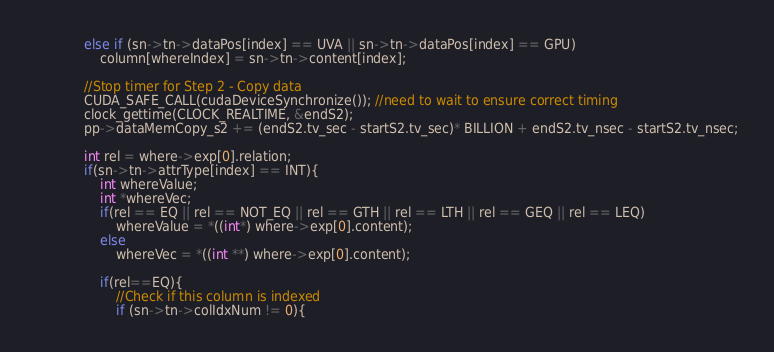<code> <loc_0><loc_0><loc_500><loc_500><_Cuda_>            else if (sn->tn->dataPos[index] == UVA || sn->tn->dataPos[index] == GPU)
                column[whereIndex] = sn->tn->content[index];

            //Stop timer for Step 2 - Copy data
            CUDA_SAFE_CALL(cudaDeviceSynchronize()); //need to wait to ensure correct timing
            clock_gettime(CLOCK_REALTIME, &endS2);
            pp->dataMemCopy_s2 += (endS2.tv_sec - startS2.tv_sec)* BILLION + endS2.tv_nsec - startS2.tv_nsec;
                
            int rel = where->exp[0].relation;
            if(sn->tn->attrType[index] == INT){
                int whereValue;
                int *whereVec;
                if(rel == EQ || rel == NOT_EQ || rel == GTH || rel == LTH || rel == GEQ || rel == LEQ)
                    whereValue = *((int*) where->exp[0].content);
                else
                    whereVec = *((int **) where->exp[0].content);

                if(rel==EQ){
                    //Check if this column is indexed
                    if (sn->tn->colIdxNum != 0){</code> 